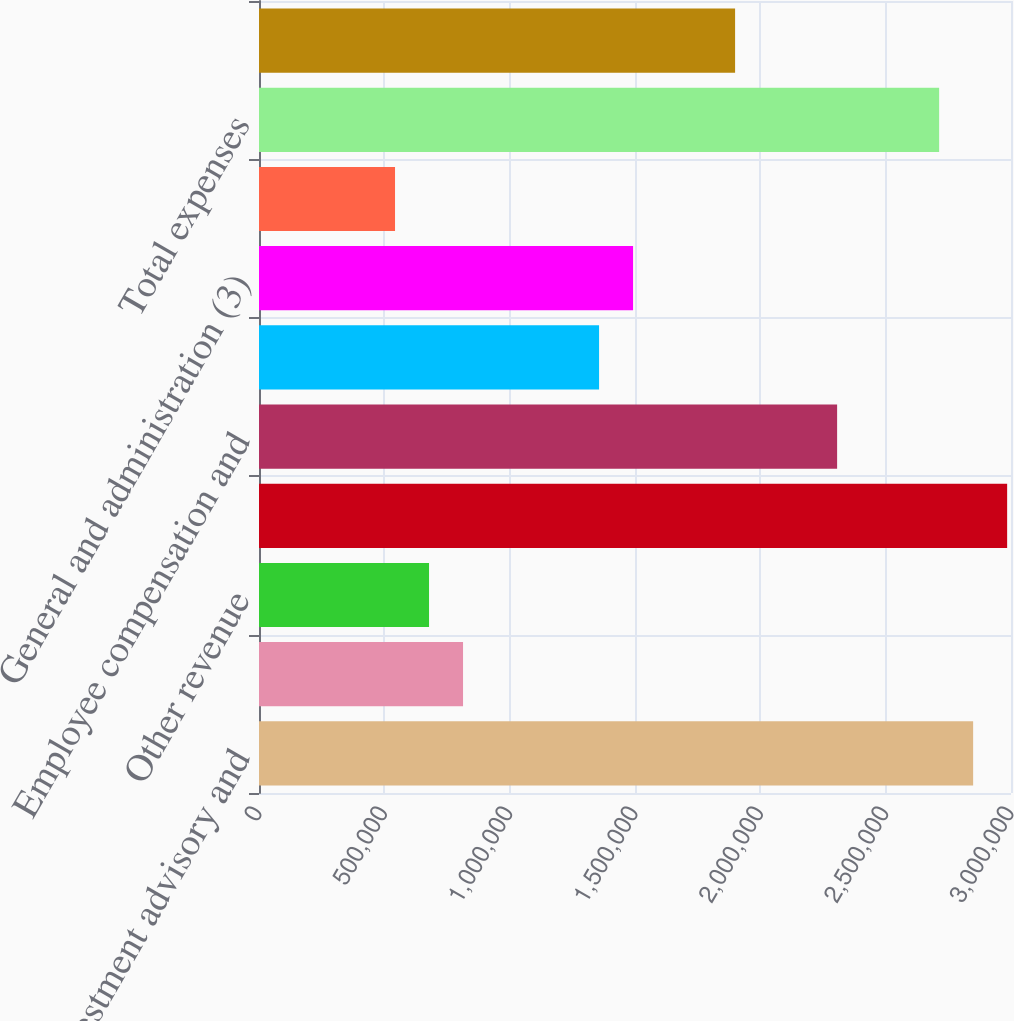Convert chart. <chart><loc_0><loc_0><loc_500><loc_500><bar_chart><fcel>Investment advisory and<fcel>BlackRock Solutions and<fcel>Other revenue<fcel>Total revenue<fcel>Employee compensation and<fcel>Portfolio administration and<fcel>General and administration (3)<fcel>Amortization of intangible<fcel>Total expenses<fcel>Operating income<nl><fcel>2.84895e+06<fcel>813987<fcel>678323<fcel>2.98461e+06<fcel>2.30629e+06<fcel>1.35664e+06<fcel>1.49231e+06<fcel>542659<fcel>2.71329e+06<fcel>1.8993e+06<nl></chart> 